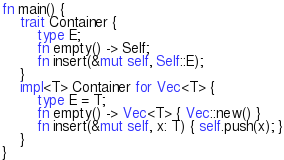<code> <loc_0><loc_0><loc_500><loc_500><_Rust_>fn main() {
    trait Container {
        type E;
        fn empty() -> Self;
        fn insert(&mut self, Self::E);
    }
    impl<T> Container for Vec<T> {
        type E = T;
        fn empty() -> Vec<T> { Vec::new() }
        fn insert(&mut self, x: T) { self.push(x); }
    }
}
</code> 